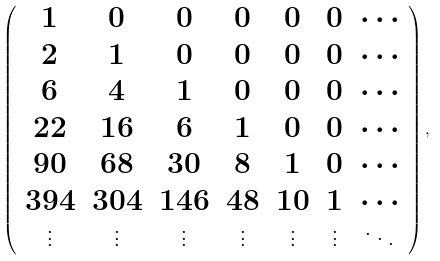<formula> <loc_0><loc_0><loc_500><loc_500>\left ( \begin{array} { c c c c c c c } 1 & 0 & 0 & 0 & 0 & 0 & \cdots \\ 2 & 1 & 0 & 0 & 0 & 0 & \cdots \\ 6 & 4 & 1 & 0 & 0 & 0 & \cdots \\ 2 2 & 1 6 & 6 & 1 & 0 & 0 & \cdots \\ 9 0 & 6 8 & 3 0 & 8 & 1 & 0 & \cdots \\ 3 9 4 & 3 0 4 & 1 4 6 & 4 8 & 1 0 & 1 & \cdots \\ \vdots & \vdots & \vdots & \vdots & \vdots & \vdots & \ddots \end{array} \right ) ,</formula> 